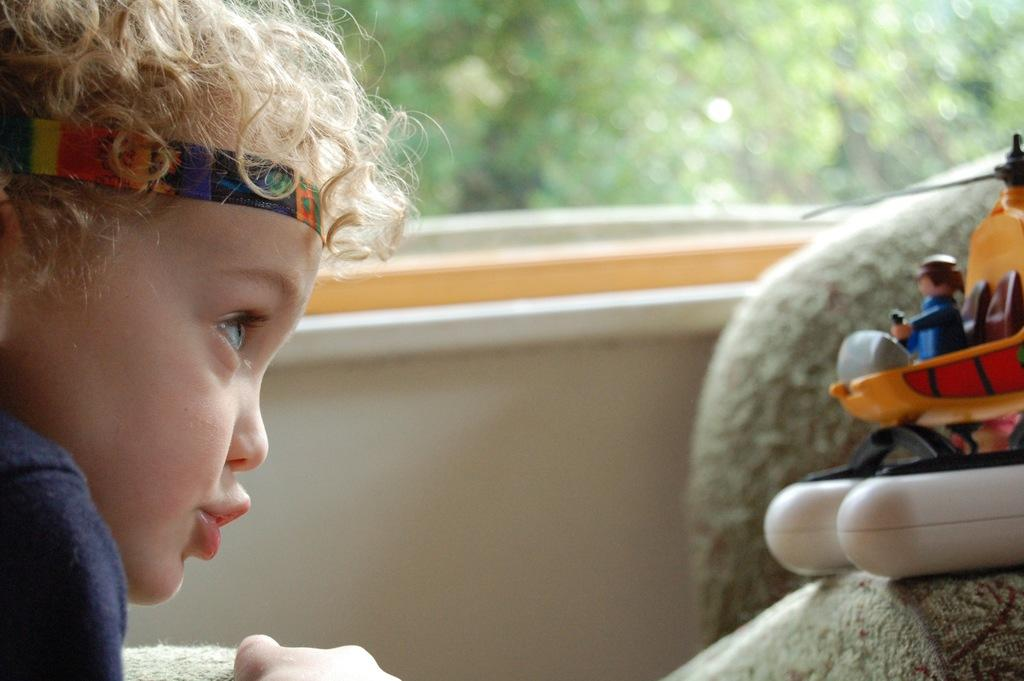What is the main subject of the image? The main subject of the image is a kid. What is the kid wearing in the image? The kid is wearing a blue shirt in the image. What can be seen on the right side of the image? There is a toy on the cloth on the right side of the image. What is visible in the background of the image? There is a window in the background of the image, and trees are visible through the window. Where is the window located in the image? The window is on a wall in the image. What type of friction can be observed between the kid and the seat in the image? There is no seat present in the image, so no friction can be observed between the kid and a seat. 